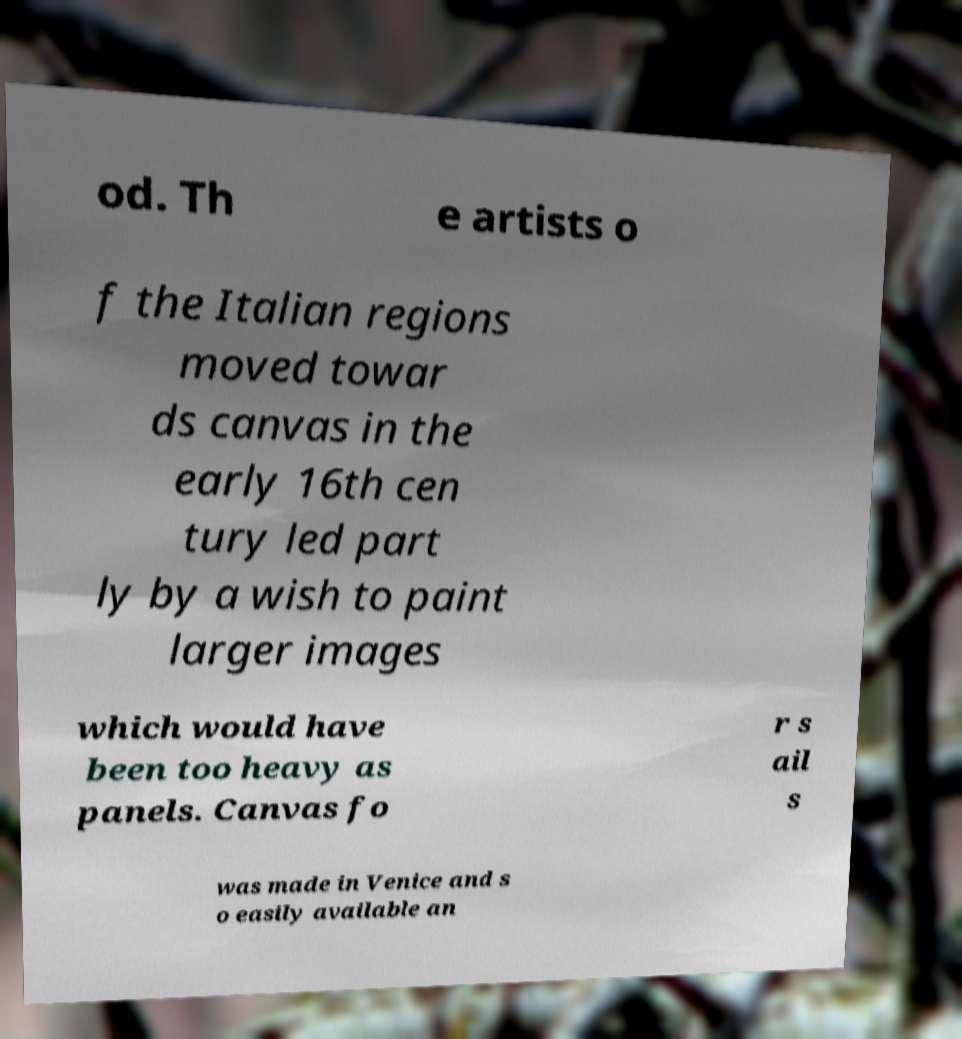Please identify and transcribe the text found in this image. od. Th e artists o f the Italian regions moved towar ds canvas in the early 16th cen tury led part ly by a wish to paint larger images which would have been too heavy as panels. Canvas fo r s ail s was made in Venice and s o easily available an 